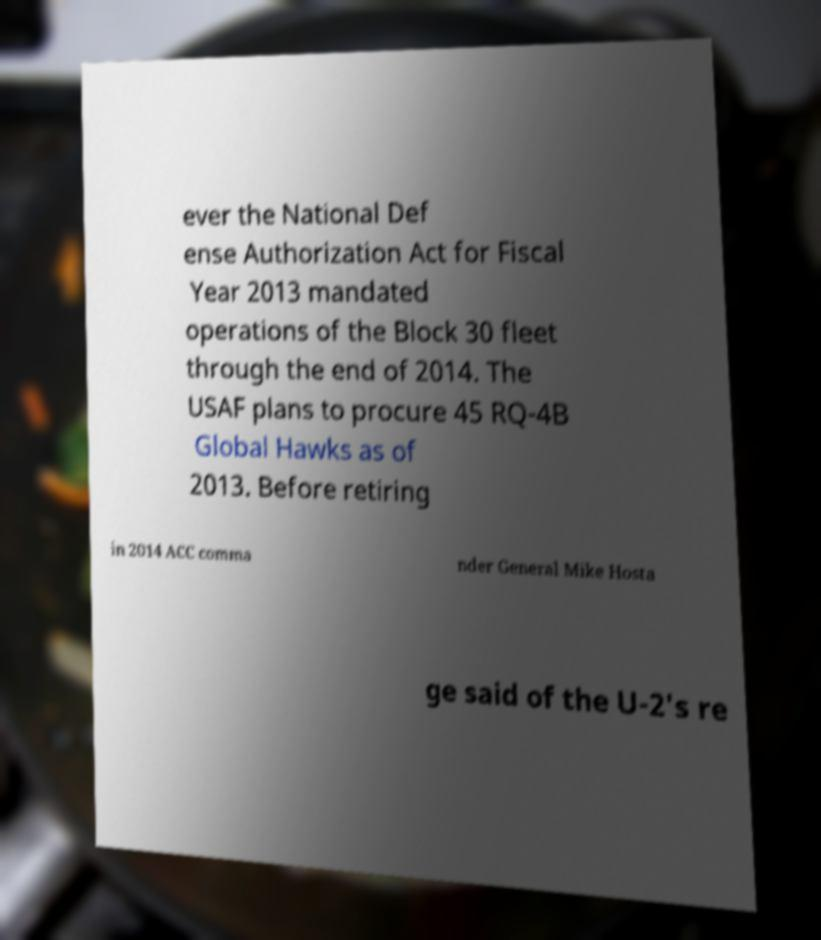Could you extract and type out the text from this image? ever the National Def ense Authorization Act for Fiscal Year 2013 mandated operations of the Block 30 fleet through the end of 2014. The USAF plans to procure 45 RQ-4B Global Hawks as of 2013. Before retiring in 2014 ACC comma nder General Mike Hosta ge said of the U-2's re 